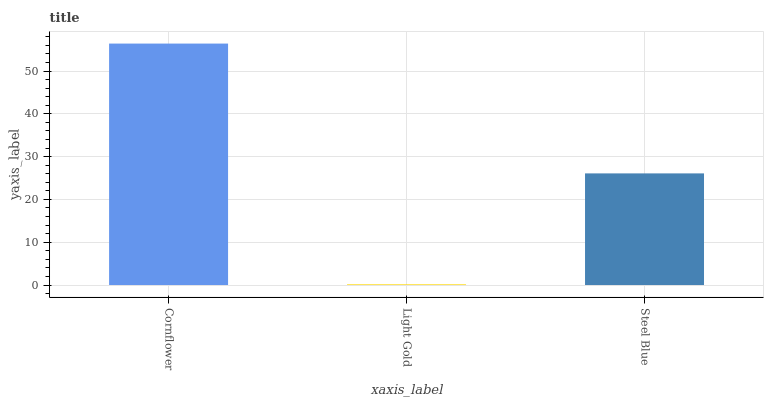Is Light Gold the minimum?
Answer yes or no. Yes. Is Cornflower the maximum?
Answer yes or no. Yes. Is Steel Blue the minimum?
Answer yes or no. No. Is Steel Blue the maximum?
Answer yes or no. No. Is Steel Blue greater than Light Gold?
Answer yes or no. Yes. Is Light Gold less than Steel Blue?
Answer yes or no. Yes. Is Light Gold greater than Steel Blue?
Answer yes or no. No. Is Steel Blue less than Light Gold?
Answer yes or no. No. Is Steel Blue the high median?
Answer yes or no. Yes. Is Steel Blue the low median?
Answer yes or no. Yes. Is Cornflower the high median?
Answer yes or no. No. Is Light Gold the low median?
Answer yes or no. No. 